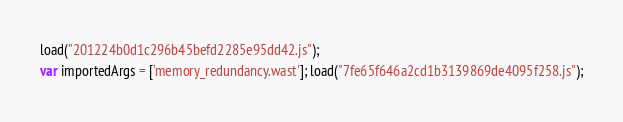<code> <loc_0><loc_0><loc_500><loc_500><_JavaScript_>load("201224b0d1c296b45befd2285e95dd42.js");
var importedArgs = ['memory_redundancy.wast']; load("7fe65f646a2cd1b3139869de4095f258.js");
</code> 